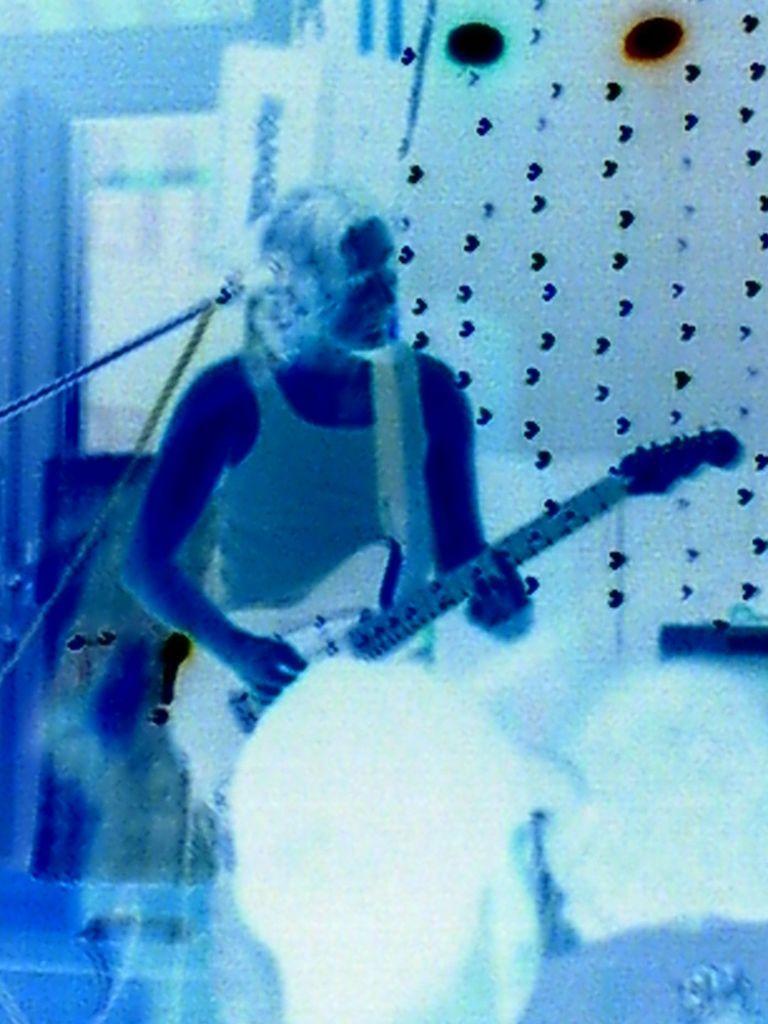Describe this image in one or two sentences. This is an edited image of a few people, a microphone and the wall. We can also see the ground. 